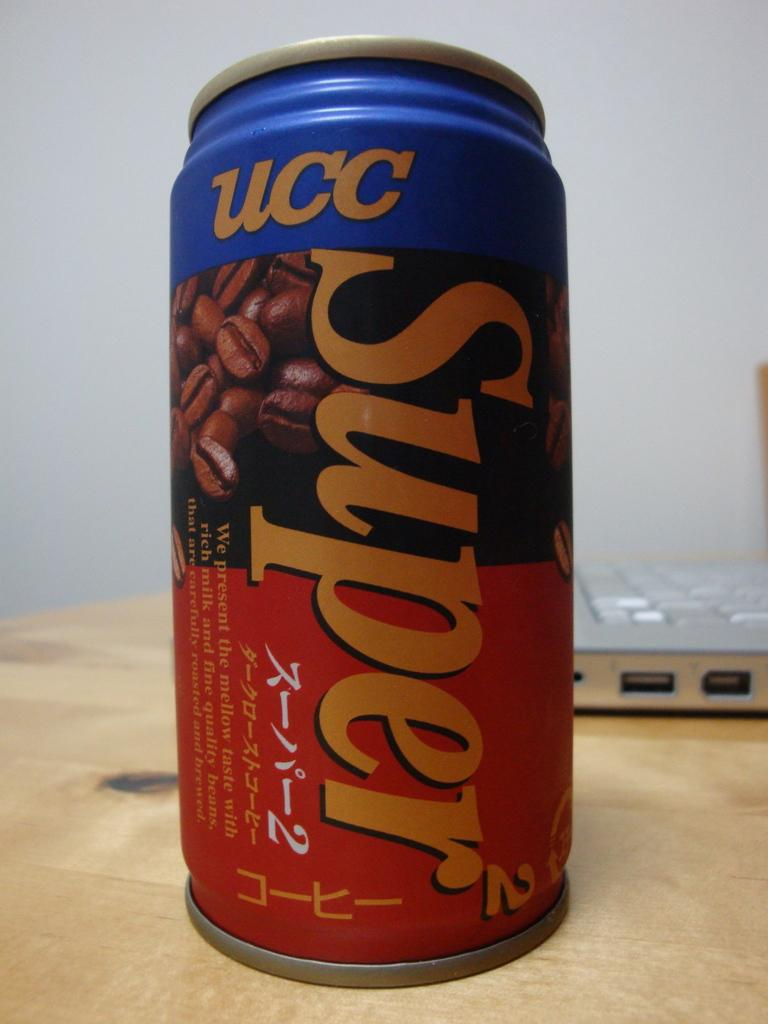<image>
Relay a brief, clear account of the picture shown. An aluminum can that reads UC super on the can 